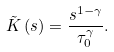Convert formula to latex. <formula><loc_0><loc_0><loc_500><loc_500>\tilde { K } \left ( s \right ) = \frac { s ^ { 1 - \gamma } } { \tau _ { 0 } ^ { \gamma } } .</formula> 